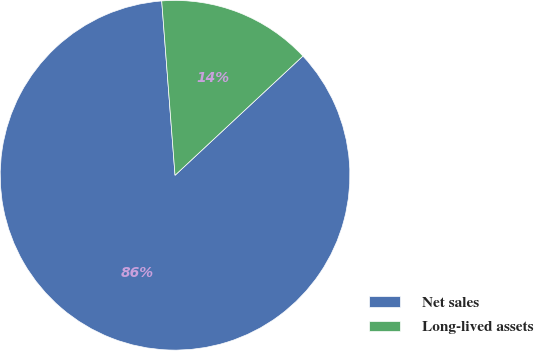Convert chart to OTSL. <chart><loc_0><loc_0><loc_500><loc_500><pie_chart><fcel>Net sales<fcel>Long-lived assets<nl><fcel>85.73%<fcel>14.27%<nl></chart> 